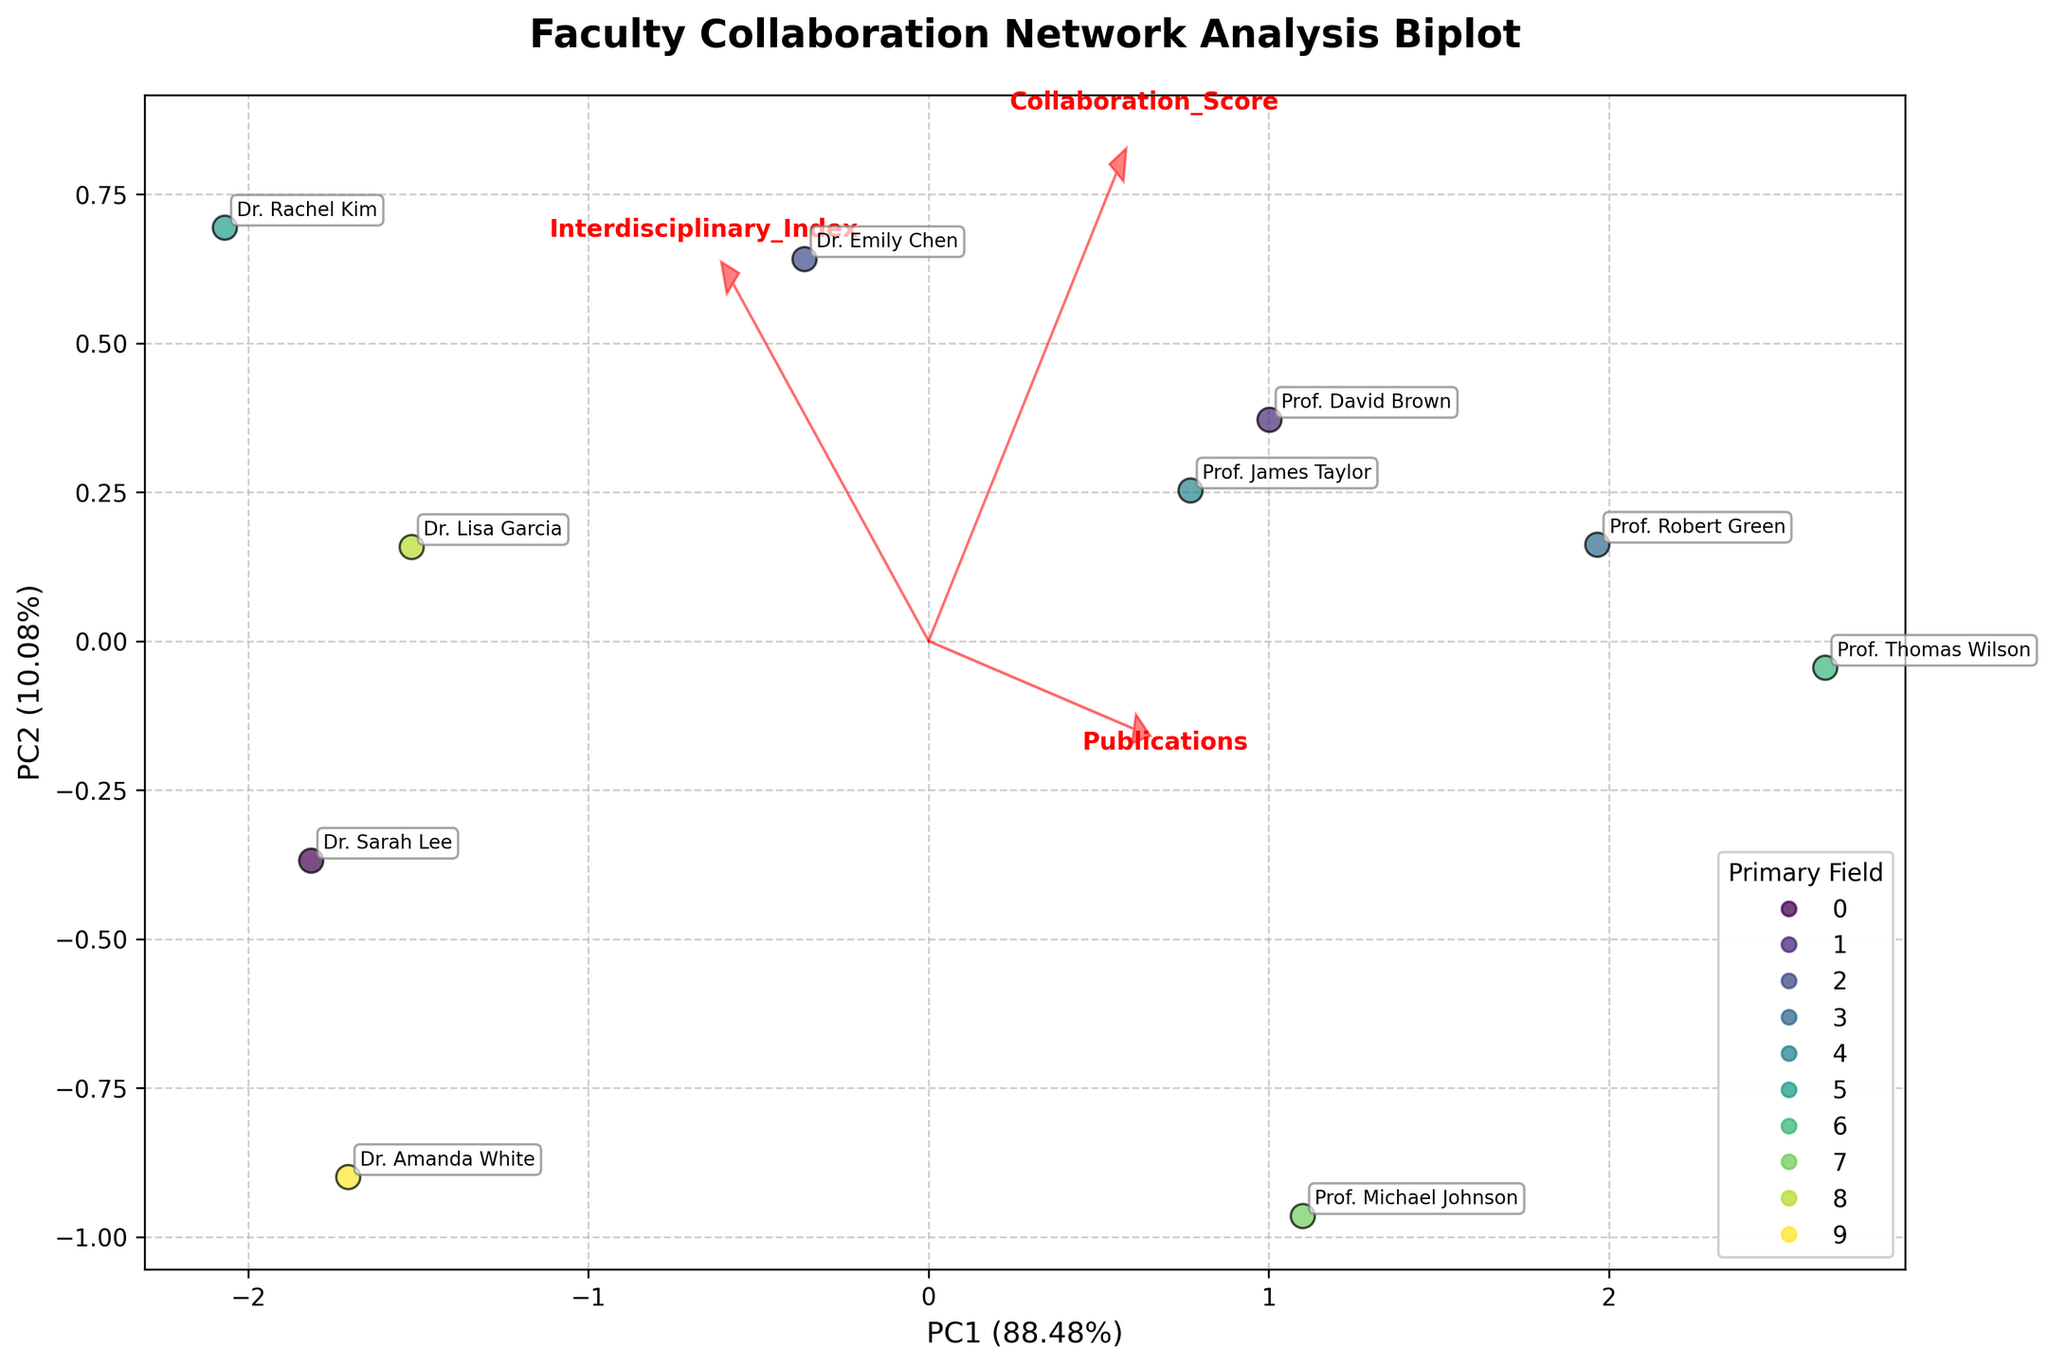How many publications does Dr. Emily Chen have? Dr. Emily Chen's publication count can be found by locating her annotated point or label on the biplot and cross-referencing it with the axis representing the number of publications.
Answer: 23 Which primary field appears to have the highest collaboration score, and who is the author? The author with the highest collaboration score can be identified by finding the point farthest along the axis associated with the collaboration score, then checking the color or label that represents their primary field and name.
Answer: Mathematics, Prof. Thomas Wilson Which feature vector has the highest contribution to the first principal component (PC1)? To determine which feature has the highest contribution to PC1, examine the red vectors indicating the directions and lengths (contributions) of the features relative to the PC1 axis. The feature with the longest arrow in the direction of PC1 has the highest contribution.
Answer: Publications How many interdisciplinary fields are represented in the biplot? Count the distinct colors of the points representing different primary fields of the authors, each color corresponds to an interdisciplinary field.
Answer: 10 What is the relationship between the interdisciplinary index and publication count for Dr. Rachel Kim? Locate Dr. Rachel Kim's point on the biplot and observe its position relative to the arrows representing the interdisciplinary index and publication count. The coordinates of her point along these arrows show her interdisciplinary index and publication count values.
Answer: Dr. Rachel Kim has an interdisciplinary index of 0.81 and 16 publications Compare the collaboration scores of Prof. David Brown and Dr. Lisa Garcia. Who has a higher collaboration score? Locate the points or labels for Prof. David Brown and Dr. Lisa Garcia, then note their positions along the collaboration score axis. Compare their values to see which one is higher.
Answer: Prof. David Brown What does the direction of the vector for the 'Interdisciplinary_Index' feature indicate? The 'Interdisciplinary_Index' vector points in a particular direction in the biplot, indicating how this feature contributes to the first two principal components (PC1 and PC2). Its direction shows positive or negative correlations with these components.
Answer: It contributes positively to both PC1 and PC2 Which author in the field of Computer Science has the least number of collaborations? Identify the point corresponding to the author in Computer Science (Dr. Emily Chen) and then check its position along the axis representing the collaboration score to determine the least number of collaborations.
Answer: Dr. Emily Chen Between Dr. Sarah Lee and Dr. Amanda White, who has a higher interdisciplinary index? Locate the points or labels for Dr. Sarah Lee and Dr. Amanda White on the biplot, then check their positions along the axis for the interdisciplinary index to compare their values.
Answer: Dr. Sarah Lee 